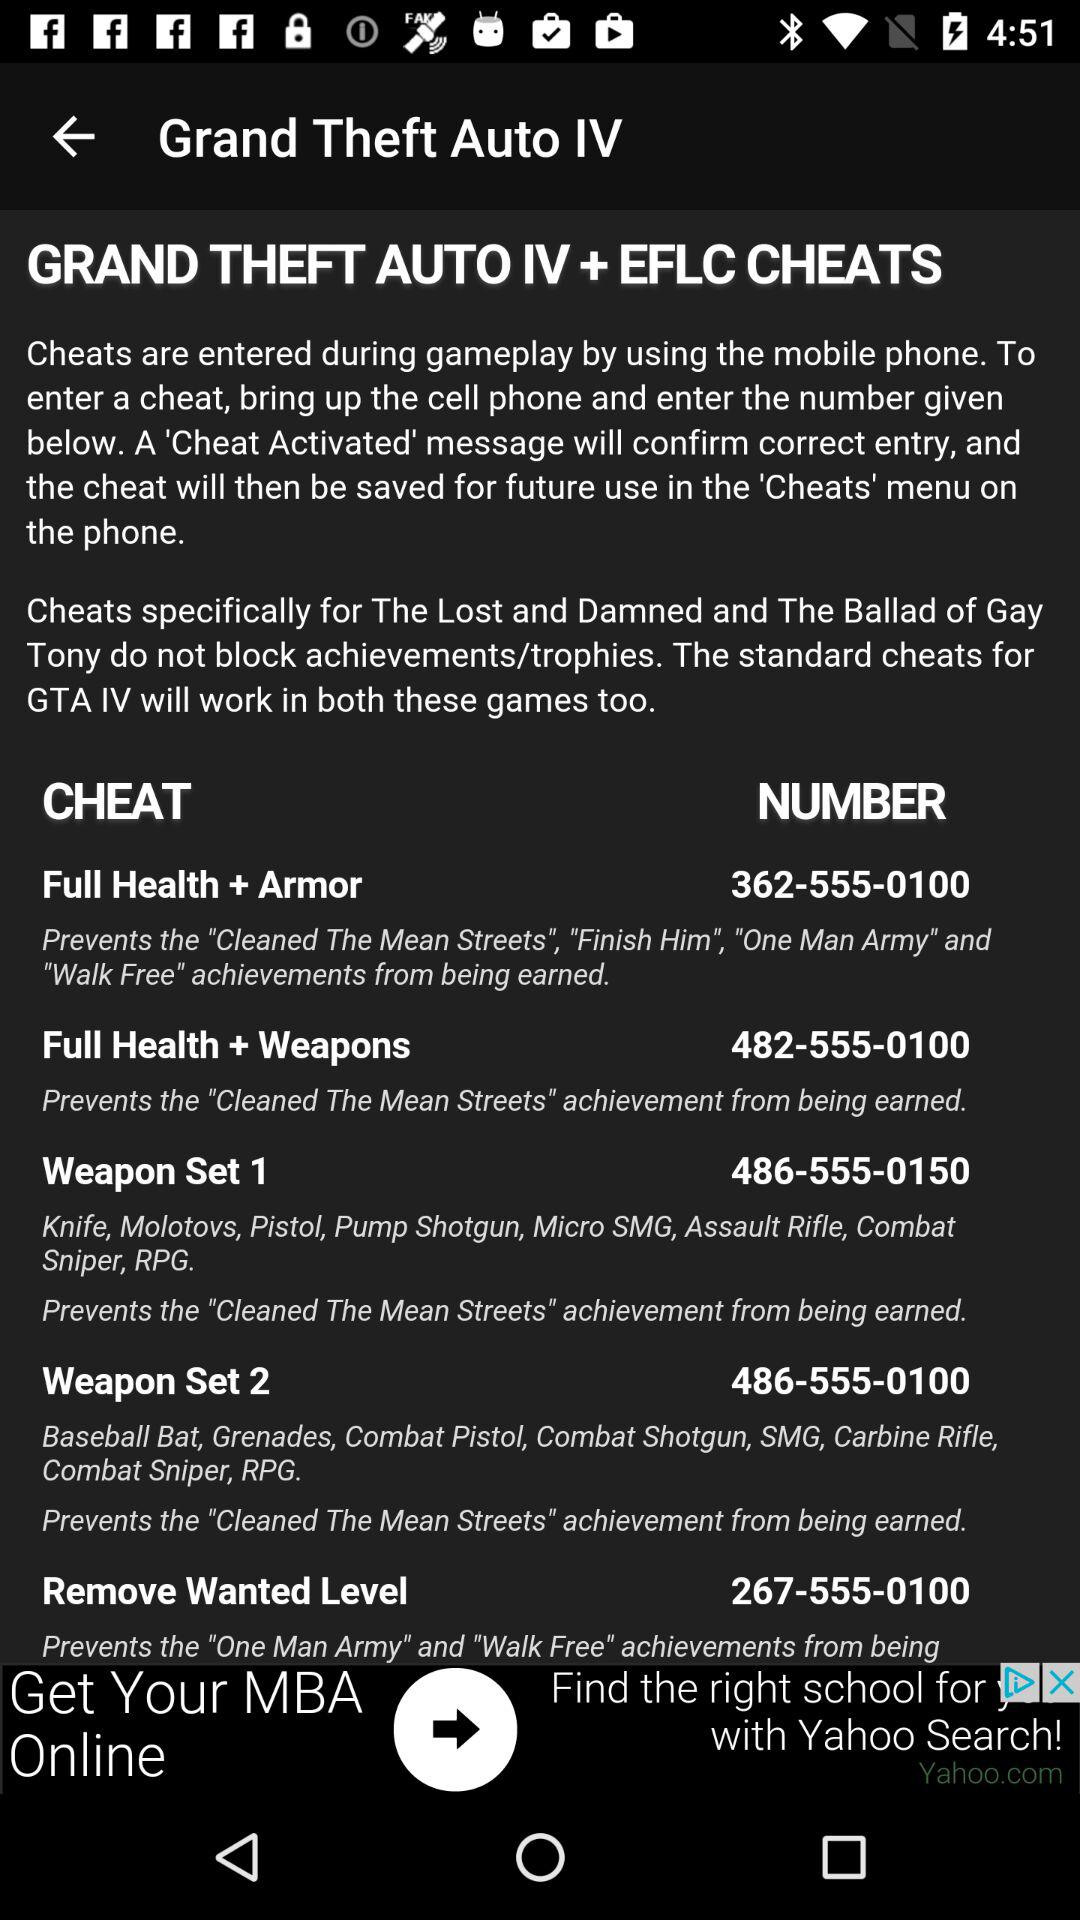What is the number to enter to activate the cheat for "Weapon Set 2"? To activate the cheat, enter the number 486-555-0100. 